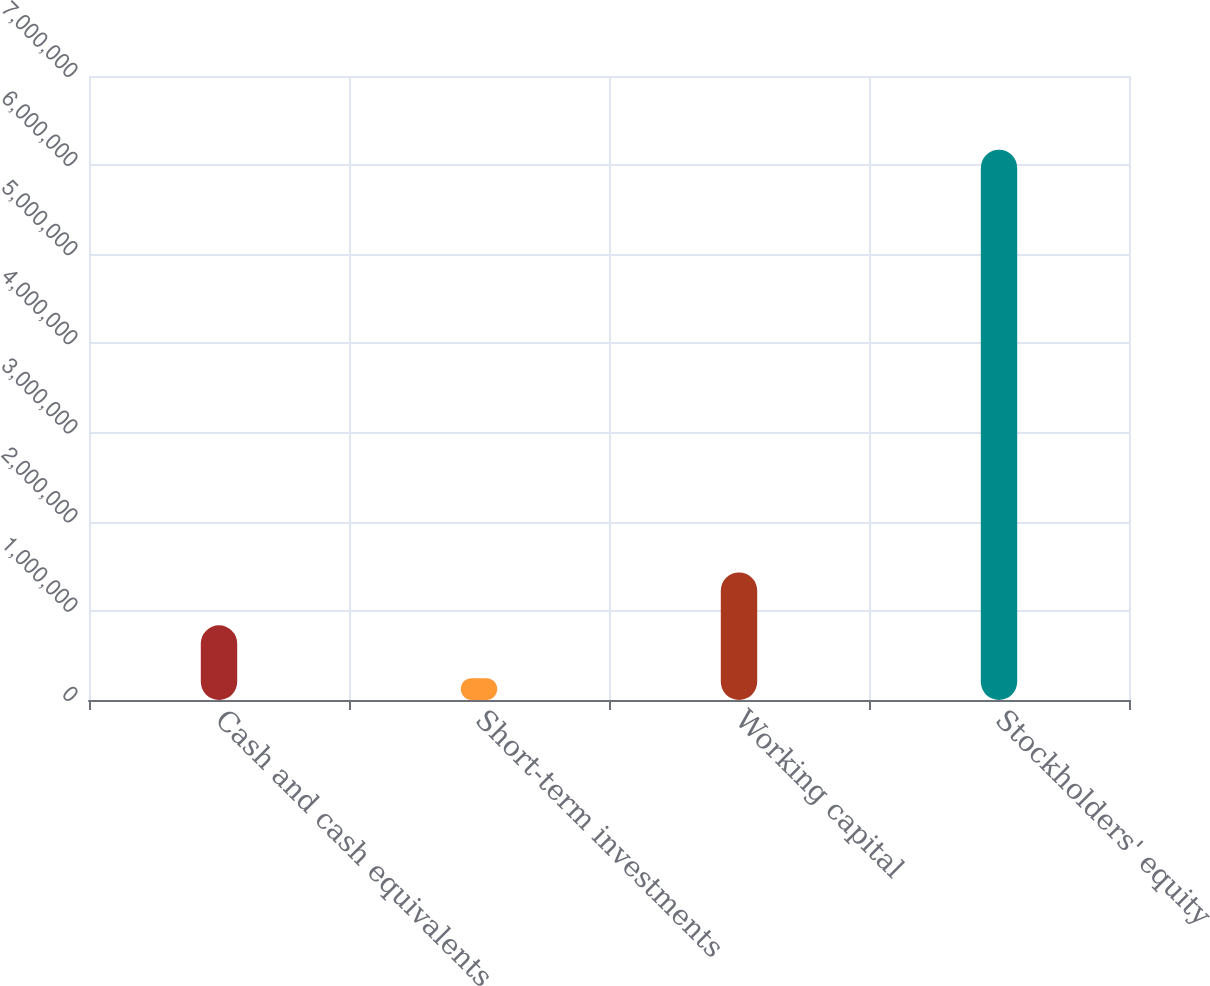<chart> <loc_0><loc_0><loc_500><loc_500><bar_chart><fcel>Cash and cash equivalents<fcel>Short-term investments<fcel>Working capital<fcel>Stockholders' equity<nl><fcel>837663<fcel>244830<fcel>1.4305e+06<fcel>6.17316e+06<nl></chart> 